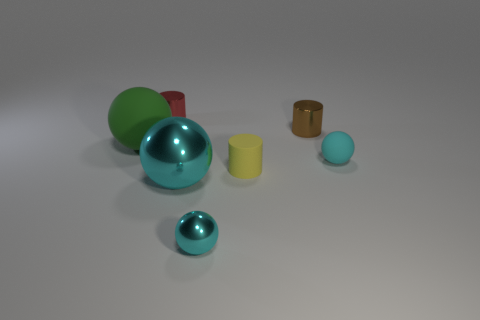Subtract all yellow cubes. How many cyan balls are left? 3 Subtract all large green balls. How many balls are left? 3 Subtract all green spheres. How many spheres are left? 3 Subtract all brown balls. Subtract all brown cylinders. How many balls are left? 4 Add 2 purple things. How many objects exist? 9 Subtract all cylinders. How many objects are left? 4 Add 3 blue cylinders. How many blue cylinders exist? 3 Subtract 0 cyan cubes. How many objects are left? 7 Subtract all small blue shiny cylinders. Subtract all large cyan objects. How many objects are left? 6 Add 4 cylinders. How many cylinders are left? 7 